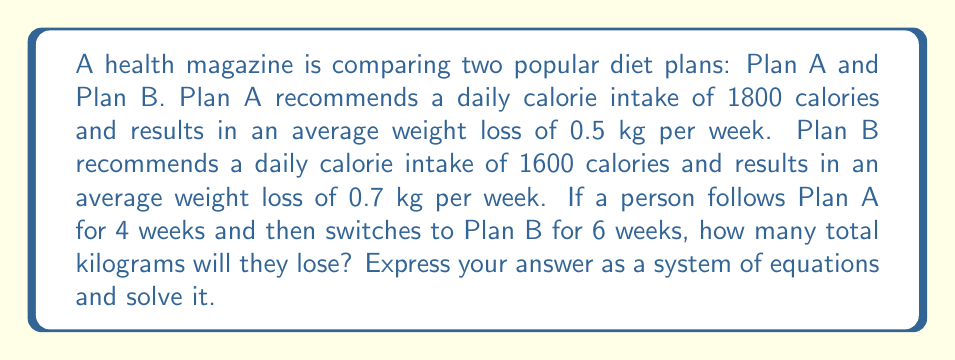Help me with this question. Let's approach this problem step by step:

1) First, let's define our variables:
   Let $x$ = weight loss from Plan A (in kg)
   Let $y$ = weight loss from Plan B (in kg)

2) Now, we can set up our system of equations:
   $$\begin{cases}
   \frac{x}{4} = 0.5 \\
   \frac{y}{6} = 0.7
   \end{cases}$$

3) Let's solve for $x$ in the first equation:
   $\frac{x}{4} = 0.5$
   $x = 0.5 \times 4 = 2$

4) Now, let's solve for $y$ in the second equation:
   $\frac{y}{6} = 0.7$
   $y = 0.7 \times 6 = 4.2$

5) The total weight loss will be the sum of $x$ and $y$:
   Total weight loss = $x + y = 2 + 4.2 = 6.2$ kg

Therefore, the person will lose a total of 6.2 kg over the 10-week period.
Answer: 6.2 kg 